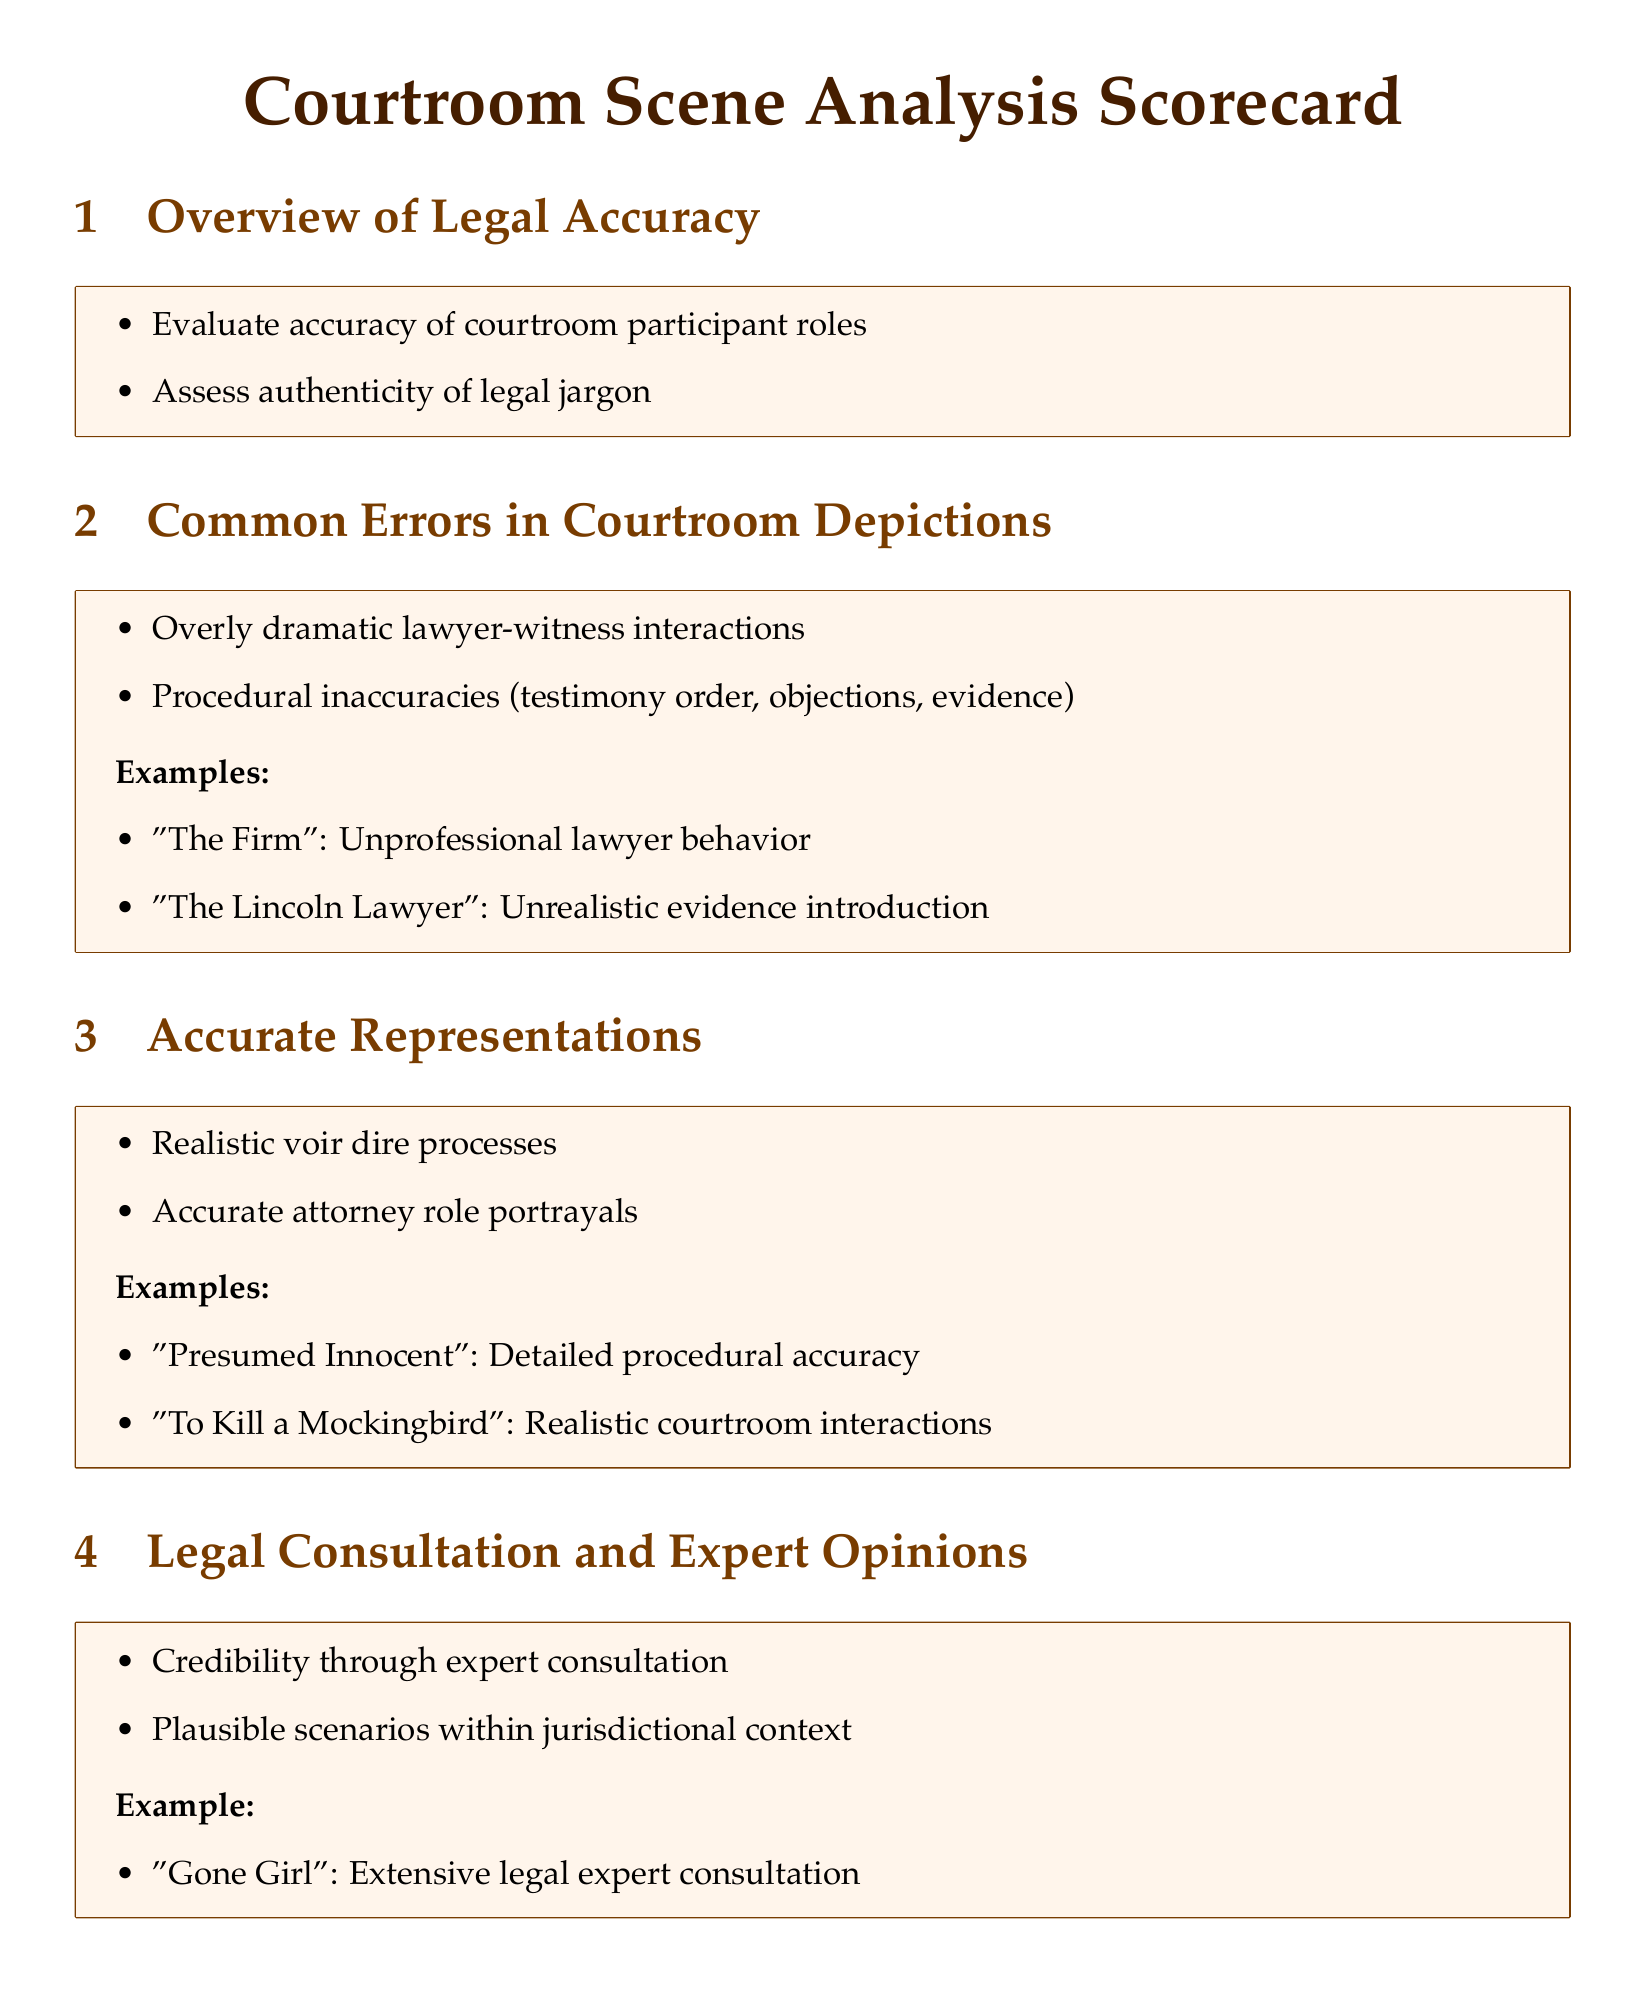What are the courtroom participant roles evaluated for accuracy? The document mentions that the scorecard evaluates the accuracy of courtroom participant roles as part of the overview of legal accuracy.
Answer: courtroom participant roles What is one example of a common error in courtroom depictions? The scorecard lists overly dramatic lawyer-witness interactions as a common error in courtroom depictions.
Answer: overly dramatic lawyer-witness interactions Which novel is cited for detailed procedural accuracy? The scorecard specifically mentions "Presumed Innocent" as an example of a novel with detailed procedural accuracy in courtroom scenes.
Answer: Presumed Innocent What is a characteristic of accurate representations in the scorecard? The scorecard outlines that realistic voir dire processes characterize accurate representations in courtroom scenes.
Answer: realistic voir dire processes What does the scorecard highlight as a key element for credibility? According to the legal consultation and expert opinions section, the document highlights expert consultation as a key element for credibility.
Answer: expert consultation How many examples of accurate representations are provided in the document? The scorecard lists two examples of accurate representations in courtroom scenes.
Answer: two What is the color used for the section titles? The scorecard uses a specific RGB color (70,30,0) for section titles as defined in the document.
Answer: RGB(70,30,0) What type of questions are used in the Scorecard? The document structure includes various short-answer questions related to courtroom scene analysis.
Answer: short-answer questions 